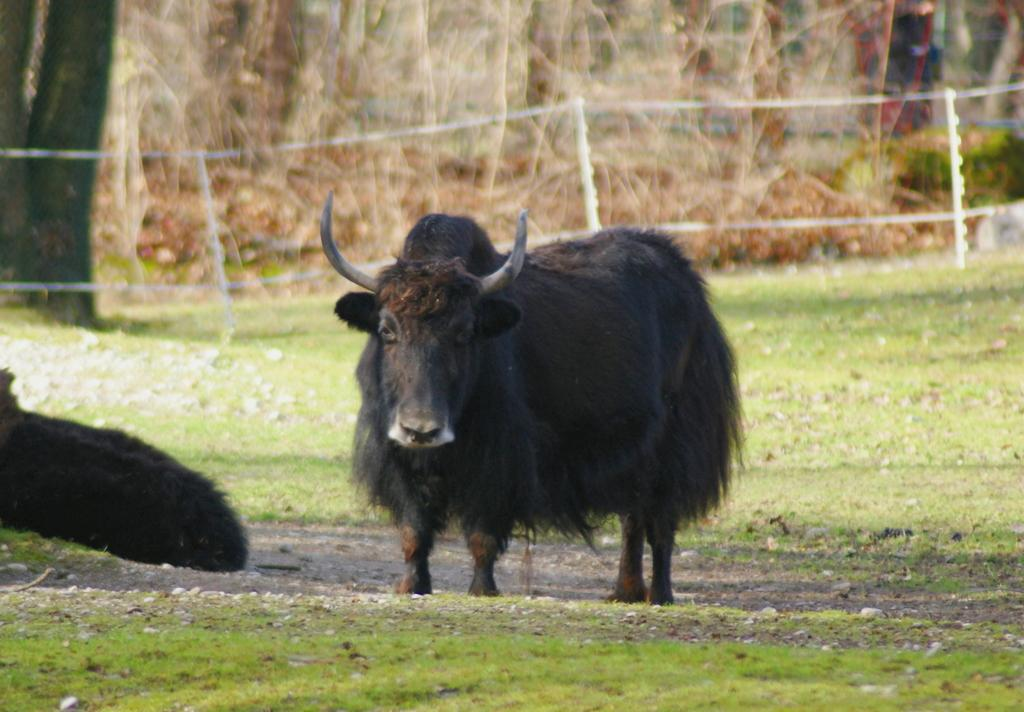What types of living organisms can be seen in the image? There are animals in the image. What type of vegetation is visible in the image? There is grass in the image. What can be seen in the background of the image? There are trees in the background of the image. What type of sack is being used to carry the attention in the image? There is no sack or attention present in the image. 